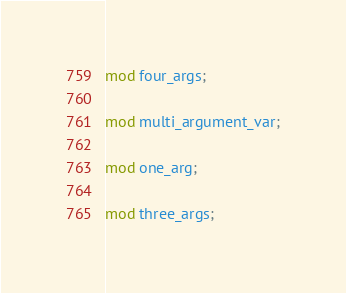Convert code to text. <code><loc_0><loc_0><loc_500><loc_500><_Rust_>
mod four_args;

mod multi_argument_var;

mod one_arg;

mod three_args;
</code> 